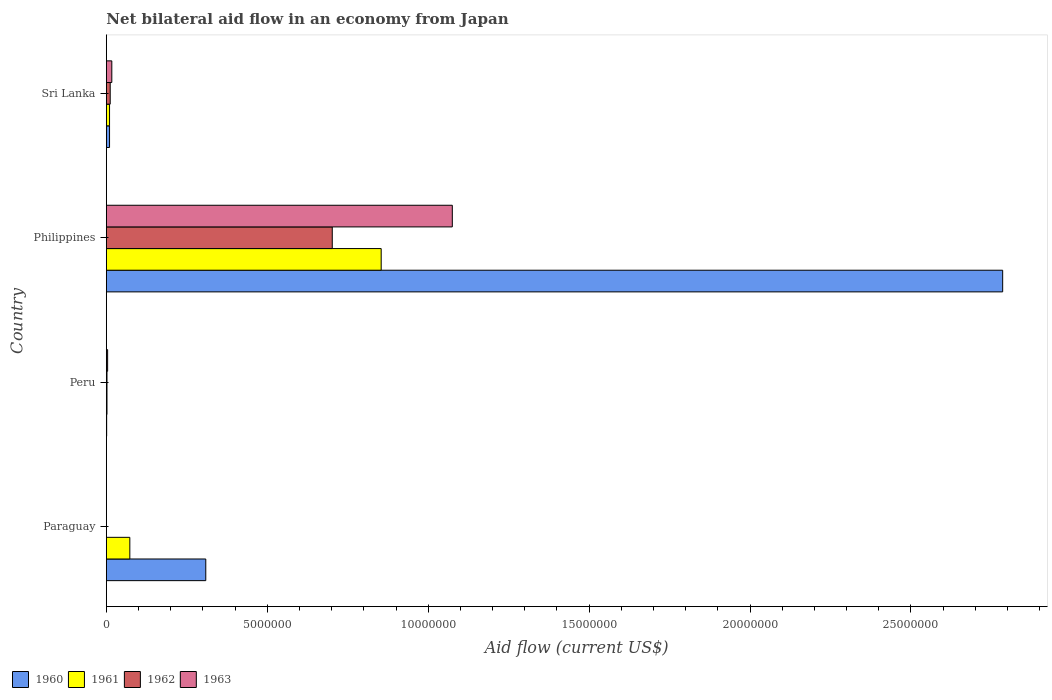How many different coloured bars are there?
Offer a very short reply. 4. How many groups of bars are there?
Your answer should be very brief. 4. Are the number of bars per tick equal to the number of legend labels?
Provide a short and direct response. No. How many bars are there on the 1st tick from the top?
Give a very brief answer. 4. In how many cases, is the number of bars for a given country not equal to the number of legend labels?
Keep it short and to the point. 1. What is the net bilateral aid flow in 1962 in Paraguay?
Give a very brief answer. 0. Across all countries, what is the maximum net bilateral aid flow in 1962?
Keep it short and to the point. 7.02e+06. In which country was the net bilateral aid flow in 1960 maximum?
Make the answer very short. Philippines. What is the total net bilateral aid flow in 1960 in the graph?
Your answer should be very brief. 3.10e+07. What is the difference between the net bilateral aid flow in 1962 in Philippines and that in Sri Lanka?
Make the answer very short. 6.90e+06. What is the difference between the net bilateral aid flow in 1960 in Sri Lanka and the net bilateral aid flow in 1961 in Philippines?
Keep it short and to the point. -8.44e+06. What is the average net bilateral aid flow in 1960 per country?
Offer a very short reply. 7.76e+06. What is the difference between the net bilateral aid flow in 1960 and net bilateral aid flow in 1961 in Sri Lanka?
Your response must be concise. 0. What is the ratio of the net bilateral aid flow in 1963 in Peru to that in Philippines?
Offer a very short reply. 0. Is the net bilateral aid flow in 1961 in Peru less than that in Sri Lanka?
Offer a terse response. Yes. Is the difference between the net bilateral aid flow in 1960 in Paraguay and Peru greater than the difference between the net bilateral aid flow in 1961 in Paraguay and Peru?
Make the answer very short. Yes. What is the difference between the highest and the second highest net bilateral aid flow in 1960?
Your response must be concise. 2.48e+07. What is the difference between the highest and the lowest net bilateral aid flow in 1960?
Your answer should be compact. 2.78e+07. Is the sum of the net bilateral aid flow in 1963 in Peru and Philippines greater than the maximum net bilateral aid flow in 1962 across all countries?
Your response must be concise. Yes. Is it the case that in every country, the sum of the net bilateral aid flow in 1962 and net bilateral aid flow in 1963 is greater than the sum of net bilateral aid flow in 1961 and net bilateral aid flow in 1960?
Offer a very short reply. No. How many bars are there?
Offer a very short reply. 14. Are all the bars in the graph horizontal?
Offer a very short reply. Yes. What is the difference between two consecutive major ticks on the X-axis?
Make the answer very short. 5.00e+06. Are the values on the major ticks of X-axis written in scientific E-notation?
Your answer should be very brief. No. Does the graph contain any zero values?
Offer a very short reply. Yes. How many legend labels are there?
Keep it short and to the point. 4. What is the title of the graph?
Your answer should be very brief. Net bilateral aid flow in an economy from Japan. What is the Aid flow (current US$) in 1960 in Paraguay?
Offer a very short reply. 3.09e+06. What is the Aid flow (current US$) of 1961 in Paraguay?
Your answer should be very brief. 7.30e+05. What is the Aid flow (current US$) in 1962 in Paraguay?
Offer a very short reply. 0. What is the Aid flow (current US$) in 1963 in Paraguay?
Your answer should be very brief. 0. What is the Aid flow (current US$) in 1961 in Peru?
Offer a terse response. 2.00e+04. What is the Aid flow (current US$) in 1962 in Peru?
Keep it short and to the point. 2.00e+04. What is the Aid flow (current US$) in 1963 in Peru?
Ensure brevity in your answer.  4.00e+04. What is the Aid flow (current US$) of 1960 in Philippines?
Offer a terse response. 2.78e+07. What is the Aid flow (current US$) of 1961 in Philippines?
Ensure brevity in your answer.  8.54e+06. What is the Aid flow (current US$) in 1962 in Philippines?
Make the answer very short. 7.02e+06. What is the Aid flow (current US$) in 1963 in Philippines?
Your response must be concise. 1.08e+07. What is the Aid flow (current US$) of 1961 in Sri Lanka?
Your answer should be compact. 1.00e+05. What is the Aid flow (current US$) of 1962 in Sri Lanka?
Keep it short and to the point. 1.20e+05. Across all countries, what is the maximum Aid flow (current US$) of 1960?
Your response must be concise. 2.78e+07. Across all countries, what is the maximum Aid flow (current US$) in 1961?
Your response must be concise. 8.54e+06. Across all countries, what is the maximum Aid flow (current US$) in 1962?
Your answer should be very brief. 7.02e+06. Across all countries, what is the maximum Aid flow (current US$) of 1963?
Your answer should be compact. 1.08e+07. Across all countries, what is the minimum Aid flow (current US$) of 1960?
Make the answer very short. 10000. What is the total Aid flow (current US$) of 1960 in the graph?
Your response must be concise. 3.10e+07. What is the total Aid flow (current US$) in 1961 in the graph?
Your answer should be very brief. 9.39e+06. What is the total Aid flow (current US$) in 1962 in the graph?
Ensure brevity in your answer.  7.16e+06. What is the total Aid flow (current US$) in 1963 in the graph?
Give a very brief answer. 1.10e+07. What is the difference between the Aid flow (current US$) in 1960 in Paraguay and that in Peru?
Your response must be concise. 3.08e+06. What is the difference between the Aid flow (current US$) in 1961 in Paraguay and that in Peru?
Your answer should be compact. 7.10e+05. What is the difference between the Aid flow (current US$) of 1960 in Paraguay and that in Philippines?
Give a very brief answer. -2.48e+07. What is the difference between the Aid flow (current US$) of 1961 in Paraguay and that in Philippines?
Offer a very short reply. -7.81e+06. What is the difference between the Aid flow (current US$) of 1960 in Paraguay and that in Sri Lanka?
Make the answer very short. 2.99e+06. What is the difference between the Aid flow (current US$) in 1961 in Paraguay and that in Sri Lanka?
Offer a very short reply. 6.30e+05. What is the difference between the Aid flow (current US$) of 1960 in Peru and that in Philippines?
Ensure brevity in your answer.  -2.78e+07. What is the difference between the Aid flow (current US$) in 1961 in Peru and that in Philippines?
Keep it short and to the point. -8.52e+06. What is the difference between the Aid flow (current US$) of 1962 in Peru and that in Philippines?
Ensure brevity in your answer.  -7.00e+06. What is the difference between the Aid flow (current US$) of 1963 in Peru and that in Philippines?
Offer a terse response. -1.07e+07. What is the difference between the Aid flow (current US$) in 1961 in Peru and that in Sri Lanka?
Your answer should be very brief. -8.00e+04. What is the difference between the Aid flow (current US$) of 1960 in Philippines and that in Sri Lanka?
Keep it short and to the point. 2.78e+07. What is the difference between the Aid flow (current US$) in 1961 in Philippines and that in Sri Lanka?
Your answer should be compact. 8.44e+06. What is the difference between the Aid flow (current US$) in 1962 in Philippines and that in Sri Lanka?
Your answer should be compact. 6.90e+06. What is the difference between the Aid flow (current US$) of 1963 in Philippines and that in Sri Lanka?
Provide a succinct answer. 1.06e+07. What is the difference between the Aid flow (current US$) in 1960 in Paraguay and the Aid flow (current US$) in 1961 in Peru?
Provide a short and direct response. 3.07e+06. What is the difference between the Aid flow (current US$) of 1960 in Paraguay and the Aid flow (current US$) of 1962 in Peru?
Give a very brief answer. 3.07e+06. What is the difference between the Aid flow (current US$) in 1960 in Paraguay and the Aid flow (current US$) in 1963 in Peru?
Make the answer very short. 3.05e+06. What is the difference between the Aid flow (current US$) in 1961 in Paraguay and the Aid flow (current US$) in 1962 in Peru?
Keep it short and to the point. 7.10e+05. What is the difference between the Aid flow (current US$) in 1961 in Paraguay and the Aid flow (current US$) in 1963 in Peru?
Provide a succinct answer. 6.90e+05. What is the difference between the Aid flow (current US$) in 1960 in Paraguay and the Aid flow (current US$) in 1961 in Philippines?
Your answer should be compact. -5.45e+06. What is the difference between the Aid flow (current US$) of 1960 in Paraguay and the Aid flow (current US$) of 1962 in Philippines?
Offer a terse response. -3.93e+06. What is the difference between the Aid flow (current US$) in 1960 in Paraguay and the Aid flow (current US$) in 1963 in Philippines?
Your response must be concise. -7.66e+06. What is the difference between the Aid flow (current US$) in 1961 in Paraguay and the Aid flow (current US$) in 1962 in Philippines?
Your answer should be very brief. -6.29e+06. What is the difference between the Aid flow (current US$) of 1961 in Paraguay and the Aid flow (current US$) of 1963 in Philippines?
Offer a very short reply. -1.00e+07. What is the difference between the Aid flow (current US$) in 1960 in Paraguay and the Aid flow (current US$) in 1961 in Sri Lanka?
Ensure brevity in your answer.  2.99e+06. What is the difference between the Aid flow (current US$) of 1960 in Paraguay and the Aid flow (current US$) of 1962 in Sri Lanka?
Keep it short and to the point. 2.97e+06. What is the difference between the Aid flow (current US$) of 1960 in Paraguay and the Aid flow (current US$) of 1963 in Sri Lanka?
Provide a succinct answer. 2.92e+06. What is the difference between the Aid flow (current US$) of 1961 in Paraguay and the Aid flow (current US$) of 1963 in Sri Lanka?
Provide a succinct answer. 5.60e+05. What is the difference between the Aid flow (current US$) in 1960 in Peru and the Aid flow (current US$) in 1961 in Philippines?
Ensure brevity in your answer.  -8.53e+06. What is the difference between the Aid flow (current US$) of 1960 in Peru and the Aid flow (current US$) of 1962 in Philippines?
Give a very brief answer. -7.01e+06. What is the difference between the Aid flow (current US$) of 1960 in Peru and the Aid flow (current US$) of 1963 in Philippines?
Ensure brevity in your answer.  -1.07e+07. What is the difference between the Aid flow (current US$) in 1961 in Peru and the Aid flow (current US$) in 1962 in Philippines?
Your answer should be very brief. -7.00e+06. What is the difference between the Aid flow (current US$) of 1961 in Peru and the Aid flow (current US$) of 1963 in Philippines?
Provide a short and direct response. -1.07e+07. What is the difference between the Aid flow (current US$) in 1962 in Peru and the Aid flow (current US$) in 1963 in Philippines?
Your answer should be compact. -1.07e+07. What is the difference between the Aid flow (current US$) in 1960 in Peru and the Aid flow (current US$) in 1963 in Sri Lanka?
Your answer should be compact. -1.60e+05. What is the difference between the Aid flow (current US$) in 1960 in Philippines and the Aid flow (current US$) in 1961 in Sri Lanka?
Give a very brief answer. 2.78e+07. What is the difference between the Aid flow (current US$) of 1960 in Philippines and the Aid flow (current US$) of 1962 in Sri Lanka?
Your response must be concise. 2.77e+07. What is the difference between the Aid flow (current US$) in 1960 in Philippines and the Aid flow (current US$) in 1963 in Sri Lanka?
Your response must be concise. 2.77e+07. What is the difference between the Aid flow (current US$) in 1961 in Philippines and the Aid flow (current US$) in 1962 in Sri Lanka?
Your answer should be very brief. 8.42e+06. What is the difference between the Aid flow (current US$) of 1961 in Philippines and the Aid flow (current US$) of 1963 in Sri Lanka?
Ensure brevity in your answer.  8.37e+06. What is the difference between the Aid flow (current US$) of 1962 in Philippines and the Aid flow (current US$) of 1963 in Sri Lanka?
Keep it short and to the point. 6.85e+06. What is the average Aid flow (current US$) in 1960 per country?
Your response must be concise. 7.76e+06. What is the average Aid flow (current US$) of 1961 per country?
Ensure brevity in your answer.  2.35e+06. What is the average Aid flow (current US$) of 1962 per country?
Offer a very short reply. 1.79e+06. What is the average Aid flow (current US$) of 1963 per country?
Provide a succinct answer. 2.74e+06. What is the difference between the Aid flow (current US$) in 1960 and Aid flow (current US$) in 1961 in Paraguay?
Your answer should be very brief. 2.36e+06. What is the difference between the Aid flow (current US$) of 1960 and Aid flow (current US$) of 1962 in Peru?
Your answer should be very brief. -10000. What is the difference between the Aid flow (current US$) in 1961 and Aid flow (current US$) in 1962 in Peru?
Give a very brief answer. 0. What is the difference between the Aid flow (current US$) of 1960 and Aid flow (current US$) of 1961 in Philippines?
Keep it short and to the point. 1.93e+07. What is the difference between the Aid flow (current US$) in 1960 and Aid flow (current US$) in 1962 in Philippines?
Give a very brief answer. 2.08e+07. What is the difference between the Aid flow (current US$) of 1960 and Aid flow (current US$) of 1963 in Philippines?
Your response must be concise. 1.71e+07. What is the difference between the Aid flow (current US$) of 1961 and Aid flow (current US$) of 1962 in Philippines?
Offer a terse response. 1.52e+06. What is the difference between the Aid flow (current US$) of 1961 and Aid flow (current US$) of 1963 in Philippines?
Provide a short and direct response. -2.21e+06. What is the difference between the Aid flow (current US$) of 1962 and Aid flow (current US$) of 1963 in Philippines?
Your answer should be very brief. -3.73e+06. What is the difference between the Aid flow (current US$) in 1960 and Aid flow (current US$) in 1963 in Sri Lanka?
Your response must be concise. -7.00e+04. What is the difference between the Aid flow (current US$) in 1961 and Aid flow (current US$) in 1962 in Sri Lanka?
Keep it short and to the point. -2.00e+04. What is the difference between the Aid flow (current US$) of 1962 and Aid flow (current US$) of 1963 in Sri Lanka?
Offer a very short reply. -5.00e+04. What is the ratio of the Aid flow (current US$) in 1960 in Paraguay to that in Peru?
Make the answer very short. 309. What is the ratio of the Aid flow (current US$) of 1961 in Paraguay to that in Peru?
Your answer should be compact. 36.5. What is the ratio of the Aid flow (current US$) of 1960 in Paraguay to that in Philippines?
Provide a short and direct response. 0.11. What is the ratio of the Aid flow (current US$) in 1961 in Paraguay to that in Philippines?
Your answer should be very brief. 0.09. What is the ratio of the Aid flow (current US$) of 1960 in Paraguay to that in Sri Lanka?
Keep it short and to the point. 30.9. What is the ratio of the Aid flow (current US$) of 1961 in Peru to that in Philippines?
Your answer should be very brief. 0. What is the ratio of the Aid flow (current US$) in 1962 in Peru to that in Philippines?
Your answer should be very brief. 0. What is the ratio of the Aid flow (current US$) of 1963 in Peru to that in Philippines?
Keep it short and to the point. 0. What is the ratio of the Aid flow (current US$) in 1962 in Peru to that in Sri Lanka?
Your answer should be very brief. 0.17. What is the ratio of the Aid flow (current US$) in 1963 in Peru to that in Sri Lanka?
Make the answer very short. 0.24. What is the ratio of the Aid flow (current US$) in 1960 in Philippines to that in Sri Lanka?
Make the answer very short. 278.5. What is the ratio of the Aid flow (current US$) of 1961 in Philippines to that in Sri Lanka?
Keep it short and to the point. 85.4. What is the ratio of the Aid flow (current US$) in 1962 in Philippines to that in Sri Lanka?
Your answer should be very brief. 58.5. What is the ratio of the Aid flow (current US$) of 1963 in Philippines to that in Sri Lanka?
Ensure brevity in your answer.  63.24. What is the difference between the highest and the second highest Aid flow (current US$) in 1960?
Your answer should be very brief. 2.48e+07. What is the difference between the highest and the second highest Aid flow (current US$) in 1961?
Keep it short and to the point. 7.81e+06. What is the difference between the highest and the second highest Aid flow (current US$) in 1962?
Make the answer very short. 6.90e+06. What is the difference between the highest and the second highest Aid flow (current US$) of 1963?
Your answer should be compact. 1.06e+07. What is the difference between the highest and the lowest Aid flow (current US$) in 1960?
Offer a very short reply. 2.78e+07. What is the difference between the highest and the lowest Aid flow (current US$) in 1961?
Offer a very short reply. 8.52e+06. What is the difference between the highest and the lowest Aid flow (current US$) in 1962?
Your answer should be very brief. 7.02e+06. What is the difference between the highest and the lowest Aid flow (current US$) in 1963?
Keep it short and to the point. 1.08e+07. 